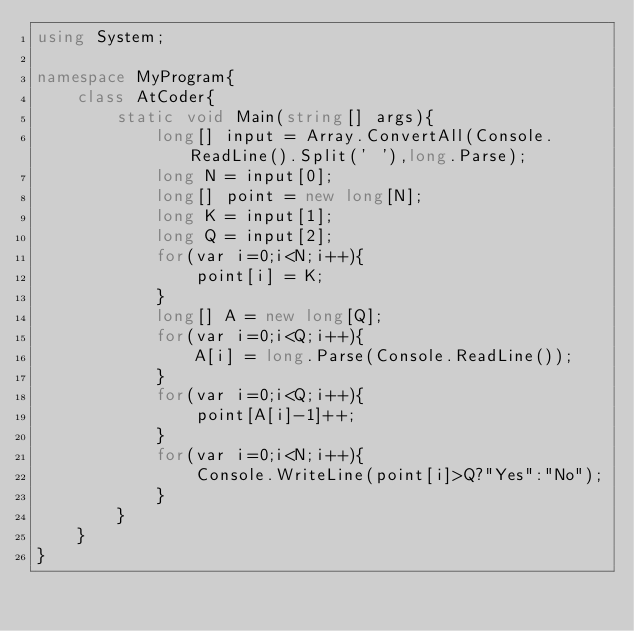Convert code to text. <code><loc_0><loc_0><loc_500><loc_500><_C#_>using System;

namespace MyProgram{
    class AtCoder{
        static void Main(string[] args){
            long[] input = Array.ConvertAll(Console.ReadLine().Split(' '),long.Parse);
            long N = input[0];
            long[] point = new long[N];
            long K = input[1];
            long Q = input[2];
            for(var i=0;i<N;i++){
                point[i] = K;
            }
            long[] A = new long[Q];
            for(var i=0;i<Q;i++){
                A[i] = long.Parse(Console.ReadLine());
            }
            for(var i=0;i<Q;i++){
                point[A[i]-1]++;
            }
            for(var i=0;i<N;i++){
                Console.WriteLine(point[i]>Q?"Yes":"No");
            }
        }
    }
}</code> 